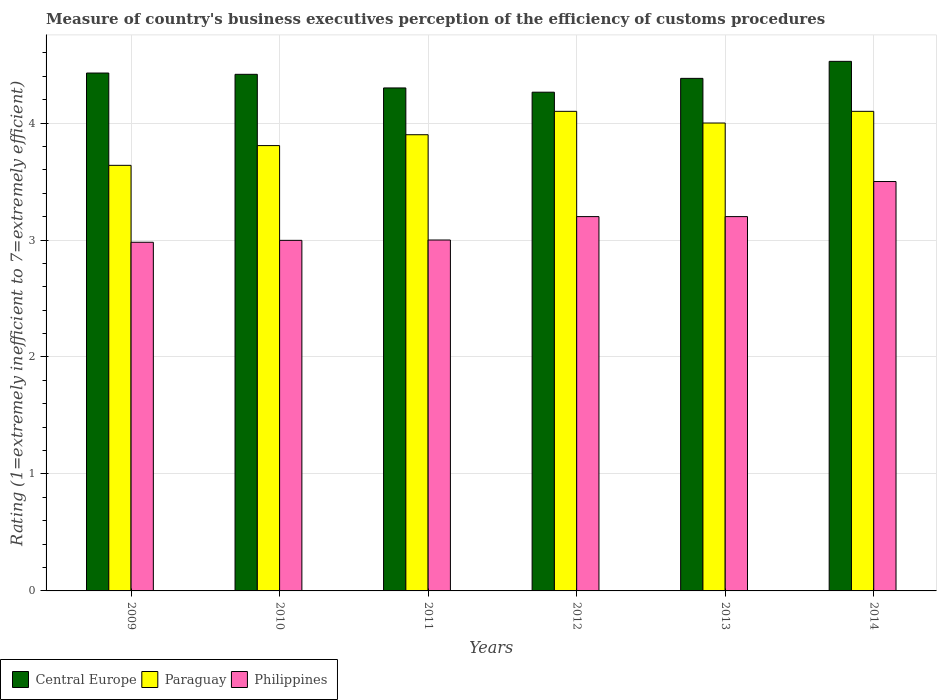How many groups of bars are there?
Your answer should be very brief. 6. Are the number of bars per tick equal to the number of legend labels?
Ensure brevity in your answer.  Yes. What is the label of the 5th group of bars from the left?
Offer a very short reply. 2013. What is the rating of the efficiency of customs procedure in Philippines in 2011?
Provide a succinct answer. 3. Across all years, what is the maximum rating of the efficiency of customs procedure in Central Europe?
Give a very brief answer. 4.53. Across all years, what is the minimum rating of the efficiency of customs procedure in Philippines?
Your response must be concise. 2.98. What is the total rating of the efficiency of customs procedure in Philippines in the graph?
Your answer should be compact. 18.88. What is the difference between the rating of the efficiency of customs procedure in Paraguay in 2011 and that in 2014?
Your answer should be very brief. -0.2. What is the difference between the rating of the efficiency of customs procedure in Philippines in 2010 and the rating of the efficiency of customs procedure in Paraguay in 2014?
Your answer should be very brief. -1.1. What is the average rating of the efficiency of customs procedure in Central Europe per year?
Your answer should be compact. 4.39. In the year 2010, what is the difference between the rating of the efficiency of customs procedure in Paraguay and rating of the efficiency of customs procedure in Philippines?
Offer a very short reply. 0.81. What is the ratio of the rating of the efficiency of customs procedure in Central Europe in 2009 to that in 2014?
Offer a terse response. 0.98. Is the rating of the efficiency of customs procedure in Philippines in 2011 less than that in 2012?
Your answer should be compact. Yes. What is the difference between the highest and the second highest rating of the efficiency of customs procedure in Paraguay?
Your response must be concise. 0. What is the difference between the highest and the lowest rating of the efficiency of customs procedure in Philippines?
Offer a very short reply. 0.52. Is the sum of the rating of the efficiency of customs procedure in Paraguay in 2009 and 2014 greater than the maximum rating of the efficiency of customs procedure in Philippines across all years?
Ensure brevity in your answer.  Yes. What does the 1st bar from the left in 2012 represents?
Keep it short and to the point. Central Europe. What does the 2nd bar from the right in 2013 represents?
Your response must be concise. Paraguay. Are all the bars in the graph horizontal?
Keep it short and to the point. No. What is the difference between two consecutive major ticks on the Y-axis?
Offer a very short reply. 1. Does the graph contain any zero values?
Your response must be concise. No. Where does the legend appear in the graph?
Provide a short and direct response. Bottom left. How many legend labels are there?
Ensure brevity in your answer.  3. How are the legend labels stacked?
Your answer should be very brief. Horizontal. What is the title of the graph?
Provide a succinct answer. Measure of country's business executives perception of the efficiency of customs procedures. What is the label or title of the X-axis?
Your answer should be compact. Years. What is the label or title of the Y-axis?
Give a very brief answer. Rating (1=extremely inefficient to 7=extremely efficient). What is the Rating (1=extremely inefficient to 7=extremely efficient) of Central Europe in 2009?
Keep it short and to the point. 4.43. What is the Rating (1=extremely inefficient to 7=extremely efficient) of Paraguay in 2009?
Provide a succinct answer. 3.64. What is the Rating (1=extremely inefficient to 7=extremely efficient) of Philippines in 2009?
Your response must be concise. 2.98. What is the Rating (1=extremely inefficient to 7=extremely efficient) in Central Europe in 2010?
Your answer should be very brief. 4.42. What is the Rating (1=extremely inefficient to 7=extremely efficient) of Paraguay in 2010?
Your response must be concise. 3.81. What is the Rating (1=extremely inefficient to 7=extremely efficient) of Philippines in 2010?
Provide a succinct answer. 3. What is the Rating (1=extremely inefficient to 7=extremely efficient) of Central Europe in 2011?
Ensure brevity in your answer.  4.3. What is the Rating (1=extremely inefficient to 7=extremely efficient) in Paraguay in 2011?
Offer a terse response. 3.9. What is the Rating (1=extremely inefficient to 7=extremely efficient) in Philippines in 2011?
Your answer should be compact. 3. What is the Rating (1=extremely inefficient to 7=extremely efficient) of Central Europe in 2012?
Provide a succinct answer. 4.26. What is the Rating (1=extremely inefficient to 7=extremely efficient) of Philippines in 2012?
Ensure brevity in your answer.  3.2. What is the Rating (1=extremely inefficient to 7=extremely efficient) of Central Europe in 2013?
Provide a short and direct response. 4.38. What is the Rating (1=extremely inefficient to 7=extremely efficient) of Paraguay in 2013?
Make the answer very short. 4. What is the Rating (1=extremely inefficient to 7=extremely efficient) of Philippines in 2013?
Provide a short and direct response. 3.2. What is the Rating (1=extremely inefficient to 7=extremely efficient) in Central Europe in 2014?
Offer a very short reply. 4.53. Across all years, what is the maximum Rating (1=extremely inefficient to 7=extremely efficient) in Central Europe?
Ensure brevity in your answer.  4.53. Across all years, what is the maximum Rating (1=extremely inefficient to 7=extremely efficient) in Paraguay?
Keep it short and to the point. 4.1. Across all years, what is the minimum Rating (1=extremely inefficient to 7=extremely efficient) of Central Europe?
Give a very brief answer. 4.26. Across all years, what is the minimum Rating (1=extremely inefficient to 7=extremely efficient) of Paraguay?
Your answer should be compact. 3.64. Across all years, what is the minimum Rating (1=extremely inefficient to 7=extremely efficient) of Philippines?
Give a very brief answer. 2.98. What is the total Rating (1=extremely inefficient to 7=extremely efficient) in Central Europe in the graph?
Your response must be concise. 26.32. What is the total Rating (1=extremely inefficient to 7=extremely efficient) of Paraguay in the graph?
Ensure brevity in your answer.  23.55. What is the total Rating (1=extremely inefficient to 7=extremely efficient) in Philippines in the graph?
Provide a short and direct response. 18.88. What is the difference between the Rating (1=extremely inefficient to 7=extremely efficient) of Central Europe in 2009 and that in 2010?
Offer a terse response. 0.01. What is the difference between the Rating (1=extremely inefficient to 7=extremely efficient) of Paraguay in 2009 and that in 2010?
Provide a short and direct response. -0.17. What is the difference between the Rating (1=extremely inefficient to 7=extremely efficient) in Philippines in 2009 and that in 2010?
Your answer should be compact. -0.02. What is the difference between the Rating (1=extremely inefficient to 7=extremely efficient) in Central Europe in 2009 and that in 2011?
Make the answer very short. 0.13. What is the difference between the Rating (1=extremely inefficient to 7=extremely efficient) in Paraguay in 2009 and that in 2011?
Give a very brief answer. -0.26. What is the difference between the Rating (1=extremely inefficient to 7=extremely efficient) of Philippines in 2009 and that in 2011?
Give a very brief answer. -0.02. What is the difference between the Rating (1=extremely inefficient to 7=extremely efficient) of Central Europe in 2009 and that in 2012?
Offer a very short reply. 0.16. What is the difference between the Rating (1=extremely inefficient to 7=extremely efficient) of Paraguay in 2009 and that in 2012?
Provide a short and direct response. -0.46. What is the difference between the Rating (1=extremely inefficient to 7=extremely efficient) of Philippines in 2009 and that in 2012?
Your answer should be compact. -0.22. What is the difference between the Rating (1=extremely inefficient to 7=extremely efficient) in Central Europe in 2009 and that in 2013?
Provide a short and direct response. 0.05. What is the difference between the Rating (1=extremely inefficient to 7=extremely efficient) of Paraguay in 2009 and that in 2013?
Your answer should be very brief. -0.36. What is the difference between the Rating (1=extremely inefficient to 7=extremely efficient) in Philippines in 2009 and that in 2013?
Your answer should be compact. -0.22. What is the difference between the Rating (1=extremely inefficient to 7=extremely efficient) in Central Europe in 2009 and that in 2014?
Your response must be concise. -0.1. What is the difference between the Rating (1=extremely inefficient to 7=extremely efficient) in Paraguay in 2009 and that in 2014?
Your response must be concise. -0.46. What is the difference between the Rating (1=extremely inefficient to 7=extremely efficient) in Philippines in 2009 and that in 2014?
Your answer should be compact. -0.52. What is the difference between the Rating (1=extremely inefficient to 7=extremely efficient) in Central Europe in 2010 and that in 2011?
Your answer should be compact. 0.12. What is the difference between the Rating (1=extremely inefficient to 7=extremely efficient) of Paraguay in 2010 and that in 2011?
Ensure brevity in your answer.  -0.09. What is the difference between the Rating (1=extremely inefficient to 7=extremely efficient) in Philippines in 2010 and that in 2011?
Provide a succinct answer. -0. What is the difference between the Rating (1=extremely inefficient to 7=extremely efficient) of Central Europe in 2010 and that in 2012?
Offer a very short reply. 0.15. What is the difference between the Rating (1=extremely inefficient to 7=extremely efficient) in Paraguay in 2010 and that in 2012?
Offer a very short reply. -0.29. What is the difference between the Rating (1=extremely inefficient to 7=extremely efficient) of Philippines in 2010 and that in 2012?
Provide a short and direct response. -0.2. What is the difference between the Rating (1=extremely inefficient to 7=extremely efficient) in Central Europe in 2010 and that in 2013?
Make the answer very short. 0.03. What is the difference between the Rating (1=extremely inefficient to 7=extremely efficient) of Paraguay in 2010 and that in 2013?
Offer a very short reply. -0.19. What is the difference between the Rating (1=extremely inefficient to 7=extremely efficient) in Philippines in 2010 and that in 2013?
Give a very brief answer. -0.2. What is the difference between the Rating (1=extremely inefficient to 7=extremely efficient) of Central Europe in 2010 and that in 2014?
Provide a succinct answer. -0.11. What is the difference between the Rating (1=extremely inefficient to 7=extremely efficient) of Paraguay in 2010 and that in 2014?
Your answer should be compact. -0.29. What is the difference between the Rating (1=extremely inefficient to 7=extremely efficient) in Philippines in 2010 and that in 2014?
Offer a terse response. -0.5. What is the difference between the Rating (1=extremely inefficient to 7=extremely efficient) in Central Europe in 2011 and that in 2012?
Provide a short and direct response. 0.04. What is the difference between the Rating (1=extremely inefficient to 7=extremely efficient) of Central Europe in 2011 and that in 2013?
Your response must be concise. -0.08. What is the difference between the Rating (1=extremely inefficient to 7=extremely efficient) in Philippines in 2011 and that in 2013?
Keep it short and to the point. -0.2. What is the difference between the Rating (1=extremely inefficient to 7=extremely efficient) in Central Europe in 2011 and that in 2014?
Your response must be concise. -0.23. What is the difference between the Rating (1=extremely inefficient to 7=extremely efficient) of Central Europe in 2012 and that in 2013?
Your answer should be compact. -0.12. What is the difference between the Rating (1=extremely inefficient to 7=extremely efficient) in Central Europe in 2012 and that in 2014?
Give a very brief answer. -0.26. What is the difference between the Rating (1=extremely inefficient to 7=extremely efficient) in Philippines in 2012 and that in 2014?
Keep it short and to the point. -0.3. What is the difference between the Rating (1=extremely inefficient to 7=extremely efficient) in Central Europe in 2013 and that in 2014?
Your answer should be compact. -0.15. What is the difference between the Rating (1=extremely inefficient to 7=extremely efficient) of Paraguay in 2013 and that in 2014?
Provide a short and direct response. -0.1. What is the difference between the Rating (1=extremely inefficient to 7=extremely efficient) in Philippines in 2013 and that in 2014?
Your answer should be very brief. -0.3. What is the difference between the Rating (1=extremely inefficient to 7=extremely efficient) of Central Europe in 2009 and the Rating (1=extremely inefficient to 7=extremely efficient) of Paraguay in 2010?
Your response must be concise. 0.62. What is the difference between the Rating (1=extremely inefficient to 7=extremely efficient) of Central Europe in 2009 and the Rating (1=extremely inefficient to 7=extremely efficient) of Philippines in 2010?
Offer a terse response. 1.43. What is the difference between the Rating (1=extremely inefficient to 7=extremely efficient) of Paraguay in 2009 and the Rating (1=extremely inefficient to 7=extremely efficient) of Philippines in 2010?
Offer a terse response. 0.64. What is the difference between the Rating (1=extremely inefficient to 7=extremely efficient) in Central Europe in 2009 and the Rating (1=extremely inefficient to 7=extremely efficient) in Paraguay in 2011?
Give a very brief answer. 0.53. What is the difference between the Rating (1=extremely inefficient to 7=extremely efficient) in Central Europe in 2009 and the Rating (1=extremely inefficient to 7=extremely efficient) in Philippines in 2011?
Give a very brief answer. 1.43. What is the difference between the Rating (1=extremely inefficient to 7=extremely efficient) of Paraguay in 2009 and the Rating (1=extremely inefficient to 7=extremely efficient) of Philippines in 2011?
Your answer should be compact. 0.64. What is the difference between the Rating (1=extremely inefficient to 7=extremely efficient) in Central Europe in 2009 and the Rating (1=extremely inefficient to 7=extremely efficient) in Paraguay in 2012?
Give a very brief answer. 0.33. What is the difference between the Rating (1=extremely inefficient to 7=extremely efficient) of Central Europe in 2009 and the Rating (1=extremely inefficient to 7=extremely efficient) of Philippines in 2012?
Provide a short and direct response. 1.23. What is the difference between the Rating (1=extremely inefficient to 7=extremely efficient) in Paraguay in 2009 and the Rating (1=extremely inefficient to 7=extremely efficient) in Philippines in 2012?
Your answer should be compact. 0.44. What is the difference between the Rating (1=extremely inefficient to 7=extremely efficient) in Central Europe in 2009 and the Rating (1=extremely inefficient to 7=extremely efficient) in Paraguay in 2013?
Keep it short and to the point. 0.43. What is the difference between the Rating (1=extremely inefficient to 7=extremely efficient) in Central Europe in 2009 and the Rating (1=extremely inefficient to 7=extremely efficient) in Philippines in 2013?
Make the answer very short. 1.23. What is the difference between the Rating (1=extremely inefficient to 7=extremely efficient) of Paraguay in 2009 and the Rating (1=extremely inefficient to 7=extremely efficient) of Philippines in 2013?
Provide a short and direct response. 0.44. What is the difference between the Rating (1=extremely inefficient to 7=extremely efficient) in Central Europe in 2009 and the Rating (1=extremely inefficient to 7=extremely efficient) in Paraguay in 2014?
Your response must be concise. 0.33. What is the difference between the Rating (1=extremely inefficient to 7=extremely efficient) of Central Europe in 2009 and the Rating (1=extremely inefficient to 7=extremely efficient) of Philippines in 2014?
Your answer should be very brief. 0.93. What is the difference between the Rating (1=extremely inefficient to 7=extremely efficient) in Paraguay in 2009 and the Rating (1=extremely inefficient to 7=extremely efficient) in Philippines in 2014?
Provide a short and direct response. 0.14. What is the difference between the Rating (1=extremely inefficient to 7=extremely efficient) of Central Europe in 2010 and the Rating (1=extremely inefficient to 7=extremely efficient) of Paraguay in 2011?
Provide a short and direct response. 0.52. What is the difference between the Rating (1=extremely inefficient to 7=extremely efficient) in Central Europe in 2010 and the Rating (1=extremely inefficient to 7=extremely efficient) in Philippines in 2011?
Offer a terse response. 1.42. What is the difference between the Rating (1=extremely inefficient to 7=extremely efficient) of Paraguay in 2010 and the Rating (1=extremely inefficient to 7=extremely efficient) of Philippines in 2011?
Offer a very short reply. 0.81. What is the difference between the Rating (1=extremely inefficient to 7=extremely efficient) of Central Europe in 2010 and the Rating (1=extremely inefficient to 7=extremely efficient) of Paraguay in 2012?
Make the answer very short. 0.32. What is the difference between the Rating (1=extremely inefficient to 7=extremely efficient) in Central Europe in 2010 and the Rating (1=extremely inefficient to 7=extremely efficient) in Philippines in 2012?
Make the answer very short. 1.22. What is the difference between the Rating (1=extremely inefficient to 7=extremely efficient) of Paraguay in 2010 and the Rating (1=extremely inefficient to 7=extremely efficient) of Philippines in 2012?
Make the answer very short. 0.61. What is the difference between the Rating (1=extremely inefficient to 7=extremely efficient) of Central Europe in 2010 and the Rating (1=extremely inefficient to 7=extremely efficient) of Paraguay in 2013?
Your response must be concise. 0.42. What is the difference between the Rating (1=extremely inefficient to 7=extremely efficient) of Central Europe in 2010 and the Rating (1=extremely inefficient to 7=extremely efficient) of Philippines in 2013?
Provide a succinct answer. 1.22. What is the difference between the Rating (1=extremely inefficient to 7=extremely efficient) of Paraguay in 2010 and the Rating (1=extremely inefficient to 7=extremely efficient) of Philippines in 2013?
Keep it short and to the point. 0.61. What is the difference between the Rating (1=extremely inefficient to 7=extremely efficient) of Central Europe in 2010 and the Rating (1=extremely inefficient to 7=extremely efficient) of Paraguay in 2014?
Ensure brevity in your answer.  0.32. What is the difference between the Rating (1=extremely inefficient to 7=extremely efficient) of Central Europe in 2010 and the Rating (1=extremely inefficient to 7=extremely efficient) of Philippines in 2014?
Offer a terse response. 0.92. What is the difference between the Rating (1=extremely inefficient to 7=extremely efficient) in Paraguay in 2010 and the Rating (1=extremely inefficient to 7=extremely efficient) in Philippines in 2014?
Offer a terse response. 0.31. What is the difference between the Rating (1=extremely inefficient to 7=extremely efficient) in Paraguay in 2011 and the Rating (1=extremely inefficient to 7=extremely efficient) in Philippines in 2013?
Offer a terse response. 0.7. What is the difference between the Rating (1=extremely inefficient to 7=extremely efficient) in Central Europe in 2011 and the Rating (1=extremely inefficient to 7=extremely efficient) in Paraguay in 2014?
Give a very brief answer. 0.2. What is the difference between the Rating (1=extremely inefficient to 7=extremely efficient) of Paraguay in 2011 and the Rating (1=extremely inefficient to 7=extremely efficient) of Philippines in 2014?
Your response must be concise. 0.4. What is the difference between the Rating (1=extremely inefficient to 7=extremely efficient) in Central Europe in 2012 and the Rating (1=extremely inefficient to 7=extremely efficient) in Paraguay in 2013?
Give a very brief answer. 0.26. What is the difference between the Rating (1=extremely inefficient to 7=extremely efficient) in Central Europe in 2012 and the Rating (1=extremely inefficient to 7=extremely efficient) in Philippines in 2013?
Ensure brevity in your answer.  1.06. What is the difference between the Rating (1=extremely inefficient to 7=extremely efficient) of Central Europe in 2012 and the Rating (1=extremely inefficient to 7=extremely efficient) of Paraguay in 2014?
Your answer should be compact. 0.16. What is the difference between the Rating (1=extremely inefficient to 7=extremely efficient) of Central Europe in 2012 and the Rating (1=extremely inefficient to 7=extremely efficient) of Philippines in 2014?
Your response must be concise. 0.76. What is the difference between the Rating (1=extremely inefficient to 7=extremely efficient) of Central Europe in 2013 and the Rating (1=extremely inefficient to 7=extremely efficient) of Paraguay in 2014?
Your answer should be compact. 0.28. What is the difference between the Rating (1=extremely inefficient to 7=extremely efficient) in Central Europe in 2013 and the Rating (1=extremely inefficient to 7=extremely efficient) in Philippines in 2014?
Your answer should be very brief. 0.88. What is the difference between the Rating (1=extremely inefficient to 7=extremely efficient) of Paraguay in 2013 and the Rating (1=extremely inefficient to 7=extremely efficient) of Philippines in 2014?
Give a very brief answer. 0.5. What is the average Rating (1=extremely inefficient to 7=extremely efficient) of Central Europe per year?
Keep it short and to the point. 4.39. What is the average Rating (1=extremely inefficient to 7=extremely efficient) in Paraguay per year?
Your answer should be compact. 3.92. What is the average Rating (1=extremely inefficient to 7=extremely efficient) of Philippines per year?
Your answer should be very brief. 3.15. In the year 2009, what is the difference between the Rating (1=extremely inefficient to 7=extremely efficient) in Central Europe and Rating (1=extremely inefficient to 7=extremely efficient) in Paraguay?
Offer a terse response. 0.79. In the year 2009, what is the difference between the Rating (1=extremely inefficient to 7=extremely efficient) of Central Europe and Rating (1=extremely inefficient to 7=extremely efficient) of Philippines?
Provide a short and direct response. 1.45. In the year 2009, what is the difference between the Rating (1=extremely inefficient to 7=extremely efficient) in Paraguay and Rating (1=extremely inefficient to 7=extremely efficient) in Philippines?
Give a very brief answer. 0.66. In the year 2010, what is the difference between the Rating (1=extremely inefficient to 7=extremely efficient) of Central Europe and Rating (1=extremely inefficient to 7=extremely efficient) of Paraguay?
Provide a succinct answer. 0.61. In the year 2010, what is the difference between the Rating (1=extremely inefficient to 7=extremely efficient) in Central Europe and Rating (1=extremely inefficient to 7=extremely efficient) in Philippines?
Make the answer very short. 1.42. In the year 2010, what is the difference between the Rating (1=extremely inefficient to 7=extremely efficient) of Paraguay and Rating (1=extremely inefficient to 7=extremely efficient) of Philippines?
Make the answer very short. 0.81. In the year 2011, what is the difference between the Rating (1=extremely inefficient to 7=extremely efficient) of Central Europe and Rating (1=extremely inefficient to 7=extremely efficient) of Philippines?
Offer a very short reply. 1.3. In the year 2012, what is the difference between the Rating (1=extremely inefficient to 7=extremely efficient) of Central Europe and Rating (1=extremely inefficient to 7=extremely efficient) of Paraguay?
Provide a succinct answer. 0.16. In the year 2012, what is the difference between the Rating (1=extremely inefficient to 7=extremely efficient) in Central Europe and Rating (1=extremely inefficient to 7=extremely efficient) in Philippines?
Offer a very short reply. 1.06. In the year 2012, what is the difference between the Rating (1=extremely inefficient to 7=extremely efficient) of Paraguay and Rating (1=extremely inefficient to 7=extremely efficient) of Philippines?
Give a very brief answer. 0.9. In the year 2013, what is the difference between the Rating (1=extremely inefficient to 7=extremely efficient) of Central Europe and Rating (1=extremely inefficient to 7=extremely efficient) of Paraguay?
Make the answer very short. 0.38. In the year 2013, what is the difference between the Rating (1=extremely inefficient to 7=extremely efficient) in Central Europe and Rating (1=extremely inefficient to 7=extremely efficient) in Philippines?
Your response must be concise. 1.18. In the year 2013, what is the difference between the Rating (1=extremely inefficient to 7=extremely efficient) of Paraguay and Rating (1=extremely inefficient to 7=extremely efficient) of Philippines?
Provide a succinct answer. 0.8. In the year 2014, what is the difference between the Rating (1=extremely inefficient to 7=extremely efficient) in Central Europe and Rating (1=extremely inefficient to 7=extremely efficient) in Paraguay?
Your answer should be compact. 0.43. In the year 2014, what is the difference between the Rating (1=extremely inefficient to 7=extremely efficient) of Central Europe and Rating (1=extremely inefficient to 7=extremely efficient) of Philippines?
Keep it short and to the point. 1.03. In the year 2014, what is the difference between the Rating (1=extremely inefficient to 7=extremely efficient) in Paraguay and Rating (1=extremely inefficient to 7=extremely efficient) in Philippines?
Provide a short and direct response. 0.6. What is the ratio of the Rating (1=extremely inefficient to 7=extremely efficient) of Paraguay in 2009 to that in 2010?
Offer a very short reply. 0.96. What is the ratio of the Rating (1=extremely inefficient to 7=extremely efficient) in Central Europe in 2009 to that in 2011?
Offer a very short reply. 1.03. What is the ratio of the Rating (1=extremely inefficient to 7=extremely efficient) of Paraguay in 2009 to that in 2011?
Your response must be concise. 0.93. What is the ratio of the Rating (1=extremely inefficient to 7=extremely efficient) of Central Europe in 2009 to that in 2012?
Ensure brevity in your answer.  1.04. What is the ratio of the Rating (1=extremely inefficient to 7=extremely efficient) of Paraguay in 2009 to that in 2012?
Keep it short and to the point. 0.89. What is the ratio of the Rating (1=extremely inefficient to 7=extremely efficient) in Philippines in 2009 to that in 2012?
Offer a very short reply. 0.93. What is the ratio of the Rating (1=extremely inefficient to 7=extremely efficient) in Central Europe in 2009 to that in 2013?
Keep it short and to the point. 1.01. What is the ratio of the Rating (1=extremely inefficient to 7=extremely efficient) of Paraguay in 2009 to that in 2013?
Provide a succinct answer. 0.91. What is the ratio of the Rating (1=extremely inefficient to 7=extremely efficient) in Philippines in 2009 to that in 2013?
Provide a succinct answer. 0.93. What is the ratio of the Rating (1=extremely inefficient to 7=extremely efficient) in Central Europe in 2009 to that in 2014?
Your response must be concise. 0.98. What is the ratio of the Rating (1=extremely inefficient to 7=extremely efficient) of Paraguay in 2009 to that in 2014?
Provide a succinct answer. 0.89. What is the ratio of the Rating (1=extremely inefficient to 7=extremely efficient) in Philippines in 2009 to that in 2014?
Provide a succinct answer. 0.85. What is the ratio of the Rating (1=extremely inefficient to 7=extremely efficient) of Central Europe in 2010 to that in 2011?
Ensure brevity in your answer.  1.03. What is the ratio of the Rating (1=extremely inefficient to 7=extremely efficient) in Paraguay in 2010 to that in 2011?
Your answer should be very brief. 0.98. What is the ratio of the Rating (1=extremely inefficient to 7=extremely efficient) of Central Europe in 2010 to that in 2012?
Provide a succinct answer. 1.04. What is the ratio of the Rating (1=extremely inefficient to 7=extremely efficient) in Philippines in 2010 to that in 2012?
Your answer should be compact. 0.94. What is the ratio of the Rating (1=extremely inefficient to 7=extremely efficient) in Central Europe in 2010 to that in 2013?
Your answer should be compact. 1.01. What is the ratio of the Rating (1=extremely inefficient to 7=extremely efficient) in Paraguay in 2010 to that in 2013?
Give a very brief answer. 0.95. What is the ratio of the Rating (1=extremely inefficient to 7=extremely efficient) of Philippines in 2010 to that in 2013?
Your response must be concise. 0.94. What is the ratio of the Rating (1=extremely inefficient to 7=extremely efficient) in Central Europe in 2010 to that in 2014?
Give a very brief answer. 0.98. What is the ratio of the Rating (1=extremely inefficient to 7=extremely efficient) in Paraguay in 2010 to that in 2014?
Make the answer very short. 0.93. What is the ratio of the Rating (1=extremely inefficient to 7=extremely efficient) of Philippines in 2010 to that in 2014?
Your answer should be compact. 0.86. What is the ratio of the Rating (1=extremely inefficient to 7=extremely efficient) in Central Europe in 2011 to that in 2012?
Your answer should be very brief. 1.01. What is the ratio of the Rating (1=extremely inefficient to 7=extremely efficient) of Paraguay in 2011 to that in 2012?
Make the answer very short. 0.95. What is the ratio of the Rating (1=extremely inefficient to 7=extremely efficient) in Central Europe in 2011 to that in 2013?
Your answer should be compact. 0.98. What is the ratio of the Rating (1=extremely inefficient to 7=extremely efficient) of Paraguay in 2011 to that in 2013?
Keep it short and to the point. 0.97. What is the ratio of the Rating (1=extremely inefficient to 7=extremely efficient) of Central Europe in 2011 to that in 2014?
Provide a short and direct response. 0.95. What is the ratio of the Rating (1=extremely inefficient to 7=extremely efficient) in Paraguay in 2011 to that in 2014?
Offer a very short reply. 0.95. What is the ratio of the Rating (1=extremely inefficient to 7=extremely efficient) of Philippines in 2011 to that in 2014?
Provide a short and direct response. 0.86. What is the ratio of the Rating (1=extremely inefficient to 7=extremely efficient) in Central Europe in 2012 to that in 2014?
Your response must be concise. 0.94. What is the ratio of the Rating (1=extremely inefficient to 7=extremely efficient) in Philippines in 2012 to that in 2014?
Offer a terse response. 0.91. What is the ratio of the Rating (1=extremely inefficient to 7=extremely efficient) in Central Europe in 2013 to that in 2014?
Make the answer very short. 0.97. What is the ratio of the Rating (1=extremely inefficient to 7=extremely efficient) of Paraguay in 2013 to that in 2014?
Provide a succinct answer. 0.98. What is the ratio of the Rating (1=extremely inefficient to 7=extremely efficient) of Philippines in 2013 to that in 2014?
Make the answer very short. 0.91. What is the difference between the highest and the second highest Rating (1=extremely inefficient to 7=extremely efficient) in Central Europe?
Make the answer very short. 0.1. What is the difference between the highest and the second highest Rating (1=extremely inefficient to 7=extremely efficient) in Paraguay?
Your response must be concise. 0. What is the difference between the highest and the second highest Rating (1=extremely inefficient to 7=extremely efficient) in Philippines?
Your response must be concise. 0.3. What is the difference between the highest and the lowest Rating (1=extremely inefficient to 7=extremely efficient) in Central Europe?
Your answer should be compact. 0.26. What is the difference between the highest and the lowest Rating (1=extremely inefficient to 7=extremely efficient) in Paraguay?
Offer a very short reply. 0.46. What is the difference between the highest and the lowest Rating (1=extremely inefficient to 7=extremely efficient) of Philippines?
Provide a succinct answer. 0.52. 